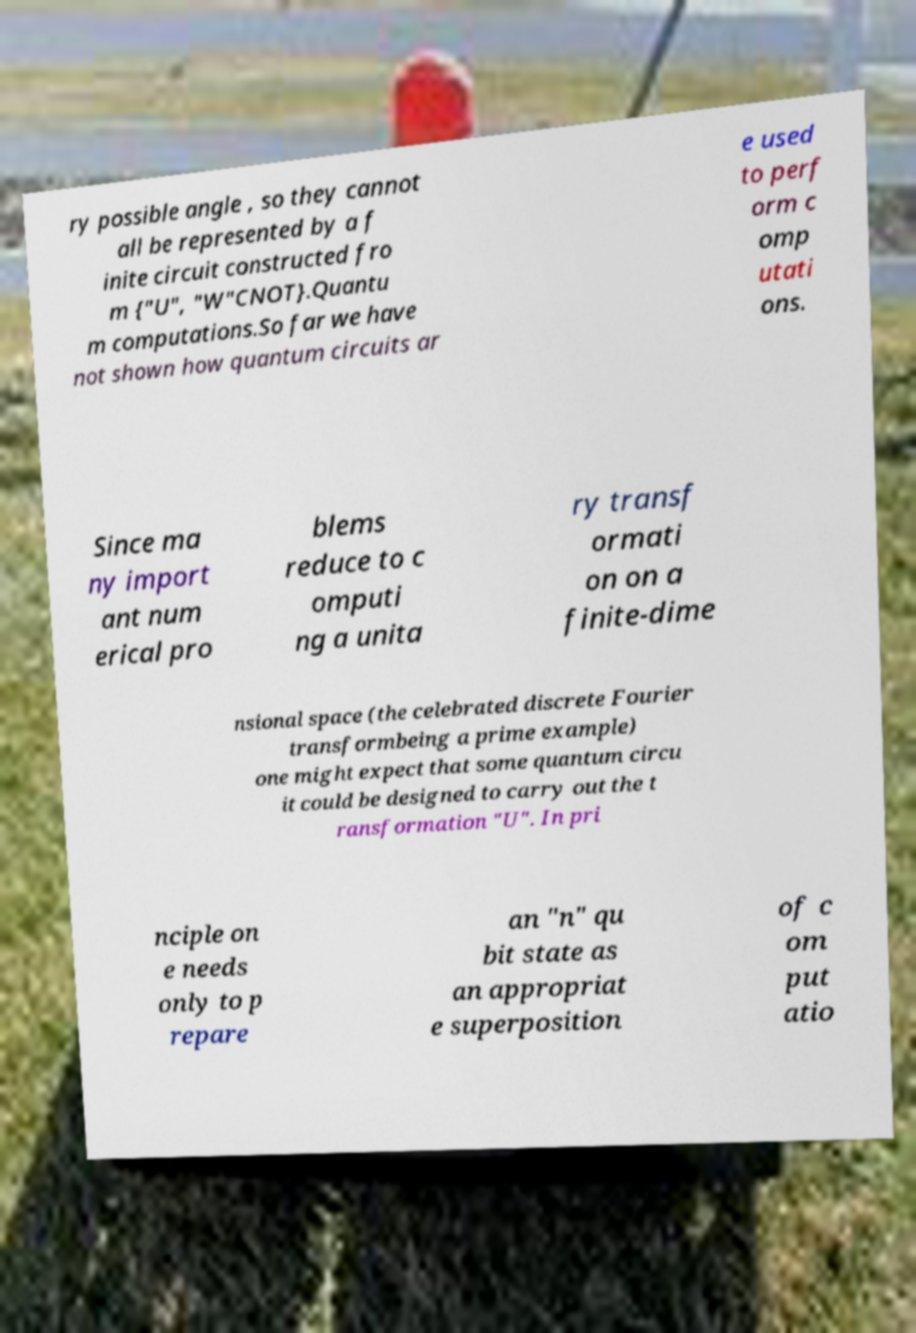For documentation purposes, I need the text within this image transcribed. Could you provide that? ry possible angle , so they cannot all be represented by a f inite circuit constructed fro m {"U", "W"CNOT}.Quantu m computations.So far we have not shown how quantum circuits ar e used to perf orm c omp utati ons. Since ma ny import ant num erical pro blems reduce to c omputi ng a unita ry transf ormati on on a finite-dime nsional space (the celebrated discrete Fourier transformbeing a prime example) one might expect that some quantum circu it could be designed to carry out the t ransformation "U". In pri nciple on e needs only to p repare an "n" qu bit state as an appropriat e superposition of c om put atio 